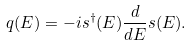<formula> <loc_0><loc_0><loc_500><loc_500>q ( E ) = - i s ^ { \dagger } ( E ) \frac { d } { d E } s ( E ) .</formula> 